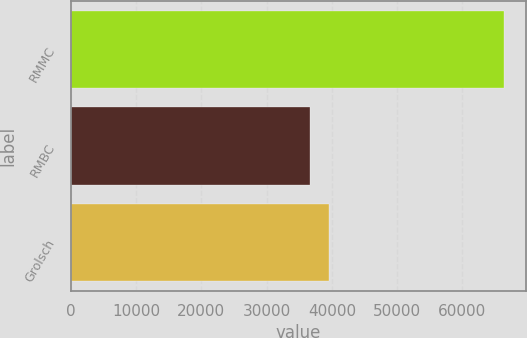<chart> <loc_0><loc_0><loc_500><loc_500><bar_chart><fcel>RMMC<fcel>RMBC<fcel>Grolsch<nl><fcel>66427<fcel>36592<fcel>39575.5<nl></chart> 